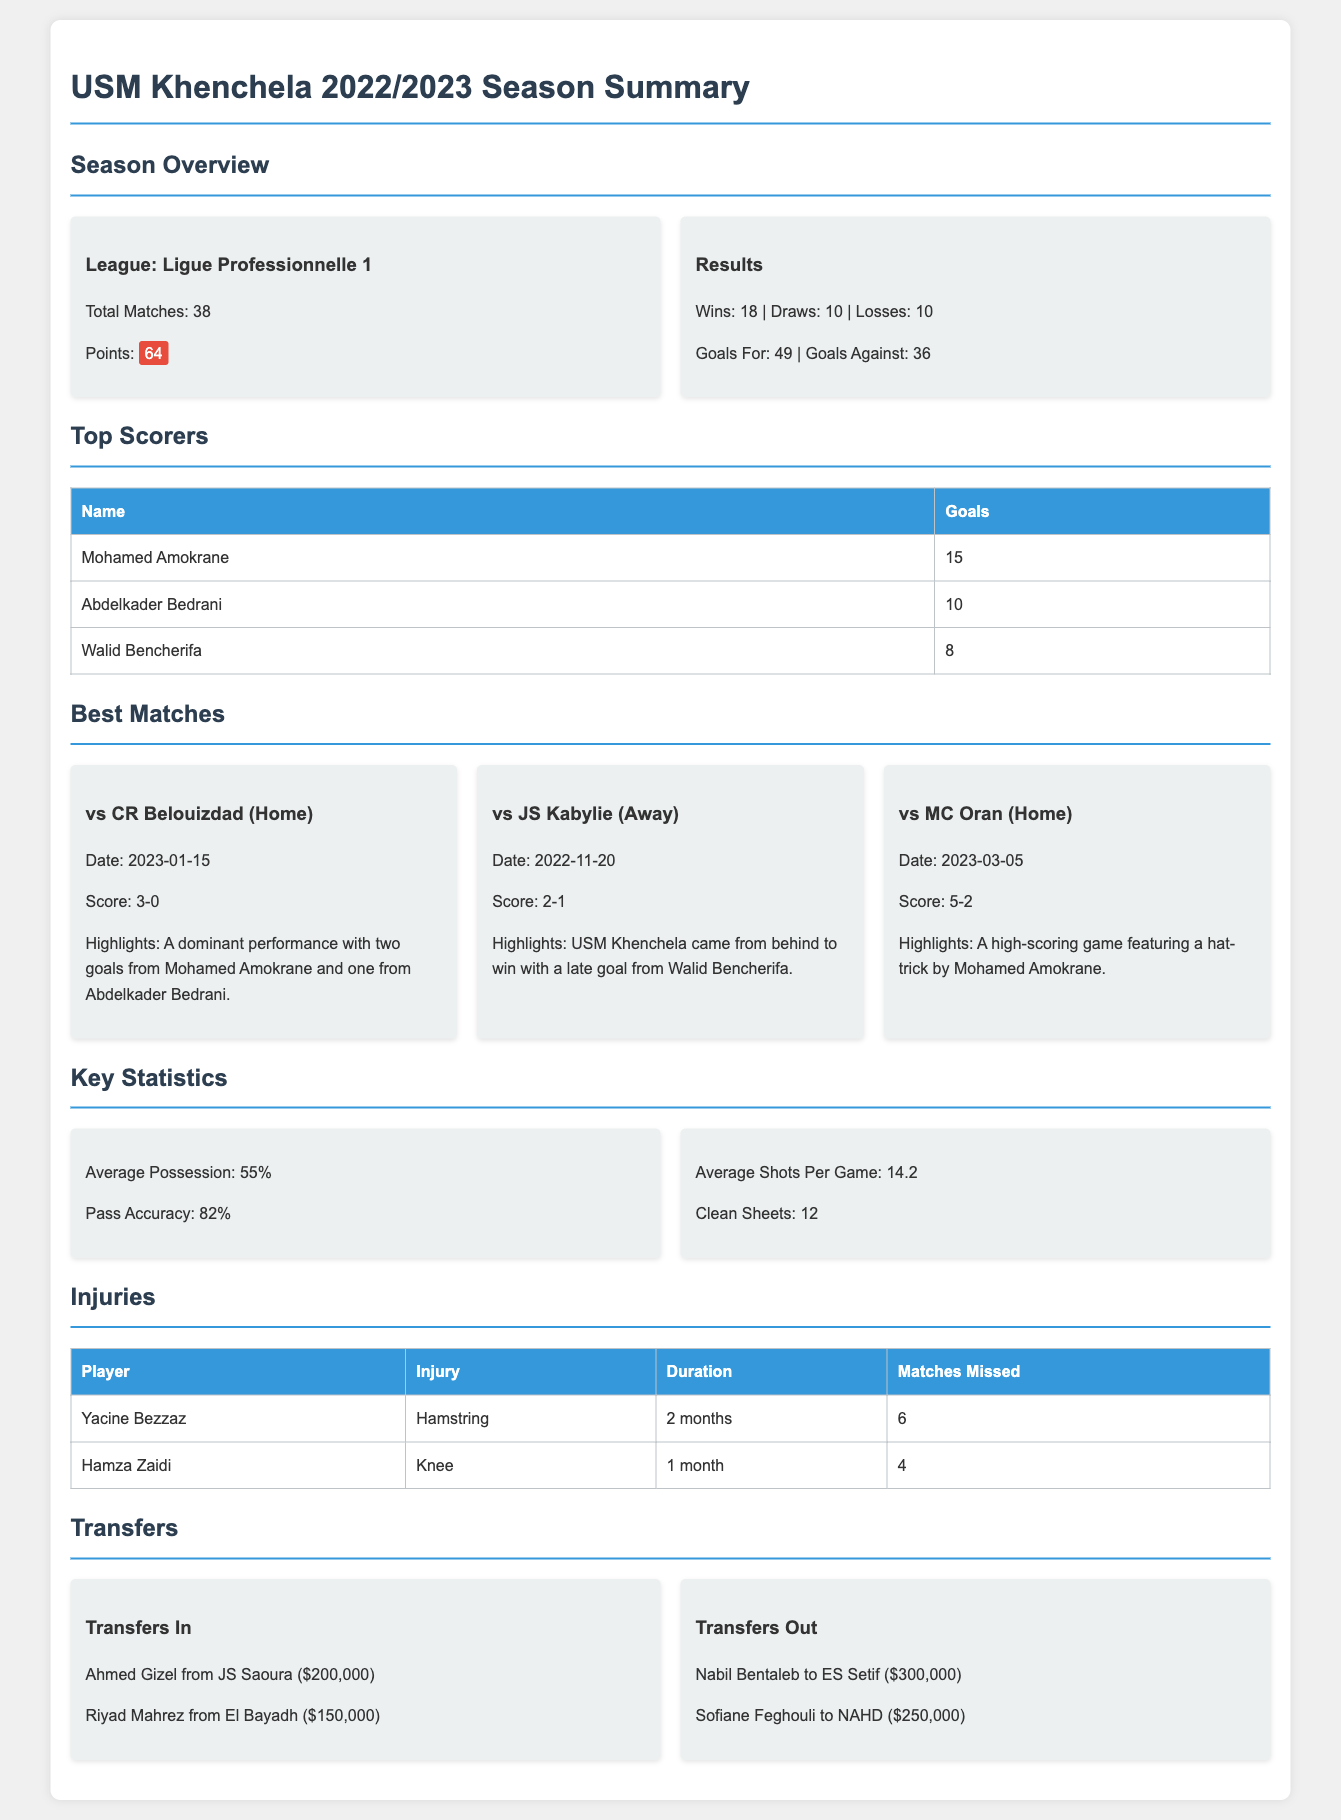What league did USM Khenchela participate in? The league mentioned in the document is Ligue Professionnelle 1.
Answer: Ligue Professionnelle 1 How many total matches did USM Khenchela play in the season? The document states that the total matches played are 38.
Answer: 38 Who was the top scorer for USM Khenchela? The document lists Mohamed Amokrane as the top scorer with 15 goals.
Answer: Mohamed Amokrane What was the score of the best match against CR Belouizdad? The score for the match against CR Belouizdad is mentioned as 3-0.
Answer: 3-0 How many draws did USM Khenchela achieve during the season? The document indicates that they had 10 draws in total.
Answer: 10 What is the average possession percentage for USM Khenchela? According to the document, the average possession is 55%.
Answer: 55% How much was Ahmed Gizel transferred for? The document states that Ahmed Gizel was transferred for $200,000.
Answer: $200,000 How many matches did Yacine Bezzaz miss due to injury? The document specifies that Yacine Bezzaz missed 6 matches.
Answer: 6 What was the number of goals conceded by USM Khenchela? The document states that they conceded 36 goals throughout the season.
Answer: 36 